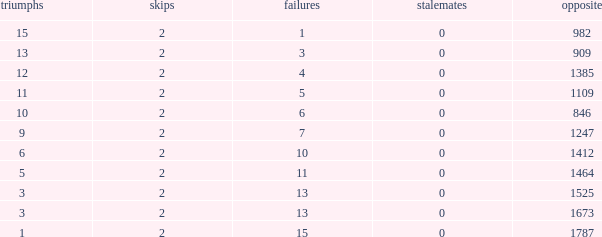What is the highest number listed under against when there were 15 losses and more than 1 win? None. 